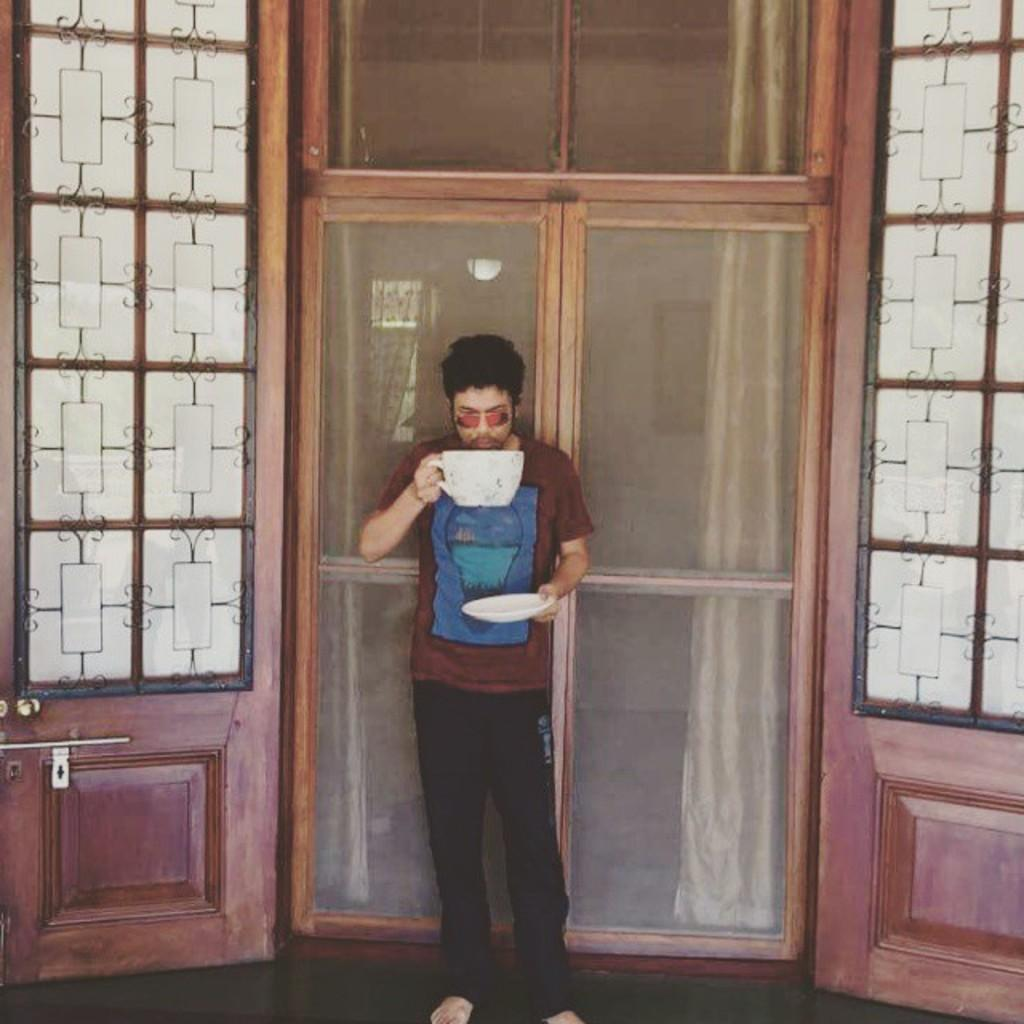What is the position of the man in the image? The man is standing on the floor in the image. What is the man wearing in the image? The man is wearing a T-shirt in the image. What is the man holding in the image? The man is holding a cup in the image. What can be seen behind the man in the image? There is a door behind the man in the image. What is visible in the background of the image? Curtains are visible in the background of the image. What type of camera is the man using to capture his territory in the image? There is no camera or mention of territory in the image; it simply shows a man standing, wearing a T-shirt, and holding a cup. 